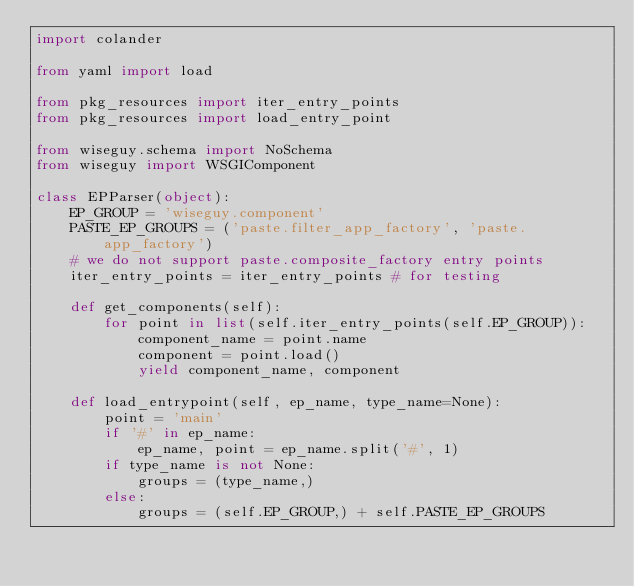<code> <loc_0><loc_0><loc_500><loc_500><_Python_>import colander

from yaml import load

from pkg_resources import iter_entry_points
from pkg_resources import load_entry_point

from wiseguy.schema import NoSchema
from wiseguy import WSGIComponent

class EPParser(object):
    EP_GROUP = 'wiseguy.component'
    PASTE_EP_GROUPS = ('paste.filter_app_factory', 'paste.app_factory')
    # we do not support paste.composite_factory entry points
    iter_entry_points = iter_entry_points # for testing

    def get_components(self):
        for point in list(self.iter_entry_points(self.EP_GROUP)):
            component_name = point.name
            component = point.load()
            yield component_name, component

    def load_entrypoint(self, ep_name, type_name=None):
        point = 'main'
        if '#' in ep_name:
            ep_name, point = ep_name.split('#', 1)
        if type_name is not None:
            groups = (type_name,)
        else:
            groups = (self.EP_GROUP,) + self.PASTE_EP_GROUPS</code> 